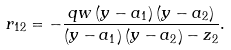Convert formula to latex. <formula><loc_0><loc_0><loc_500><loc_500>r _ { 1 2 } = - \frac { q w \left ( y - a _ { 1 } \right ) \left ( y - a _ { 2 } \right ) } { \left ( y - a _ { 1 } \right ) \left ( y - a _ { 2 } \right ) - z _ { 2 } } .</formula> 